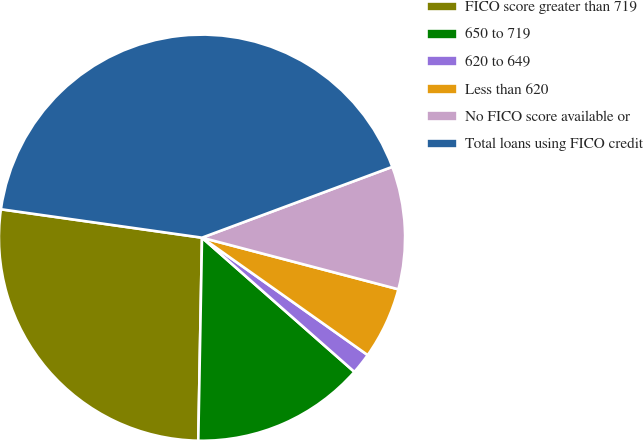Convert chart. <chart><loc_0><loc_0><loc_500><loc_500><pie_chart><fcel>FICO score greater than 719<fcel>650 to 719<fcel>620 to 649<fcel>Less than 620<fcel>No FICO score available or<fcel>Total loans using FICO credit<nl><fcel>26.94%<fcel>13.8%<fcel>1.68%<fcel>5.72%<fcel>9.76%<fcel>42.09%<nl></chart> 